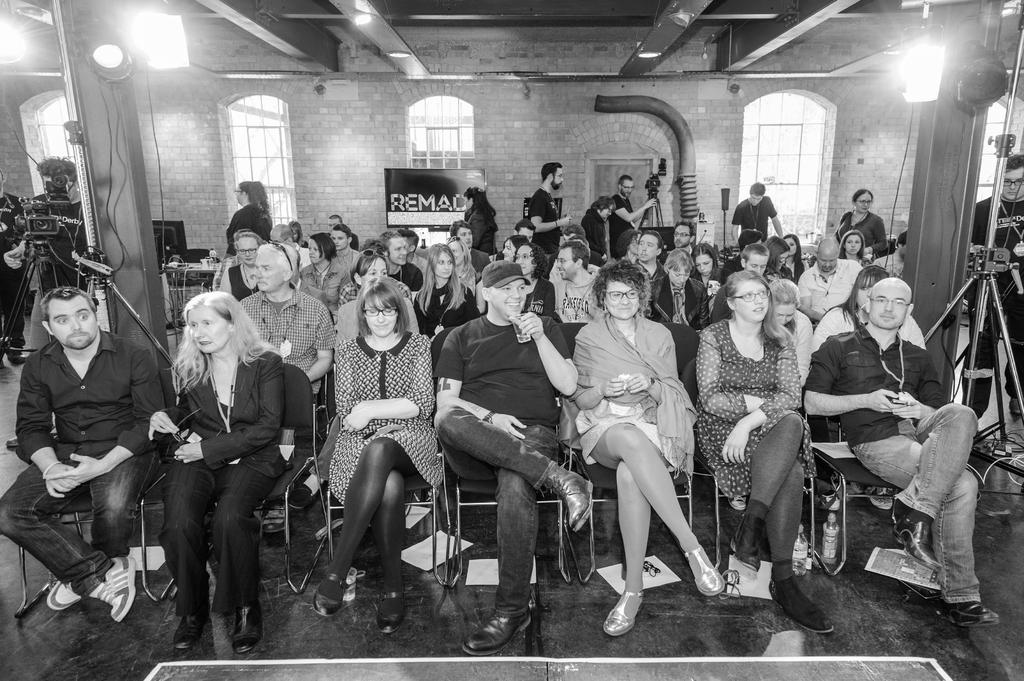What is the color scheme of the image? The image is black and white. What can be seen in the center of the image? There are people sitting on chairs in the center of the image. What is visible in the background of the image? There is a window and a wall in the background of the image. How many frogs are sitting on the chairs in the image? There are no frogs present in the image; it features people sitting on chairs. What type of suit is being worn by the people in the image? The image is black and white, and there is no indication of clothing, so it cannot be determined if anyone is wearing a suit. 